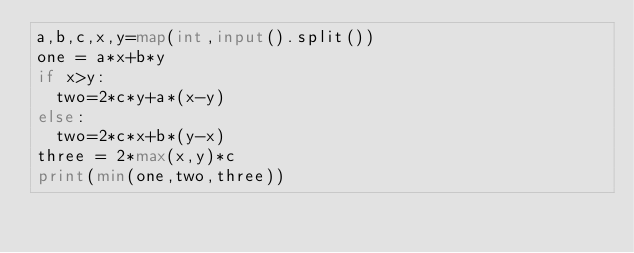Convert code to text. <code><loc_0><loc_0><loc_500><loc_500><_Python_>a,b,c,x,y=map(int,input().split())
one = a*x+b*y
if x>y:
  two=2*c*y+a*(x-y)
else:
  two=2*c*x+b*(y-x)
three = 2*max(x,y)*c
print(min(one,two,three))</code> 